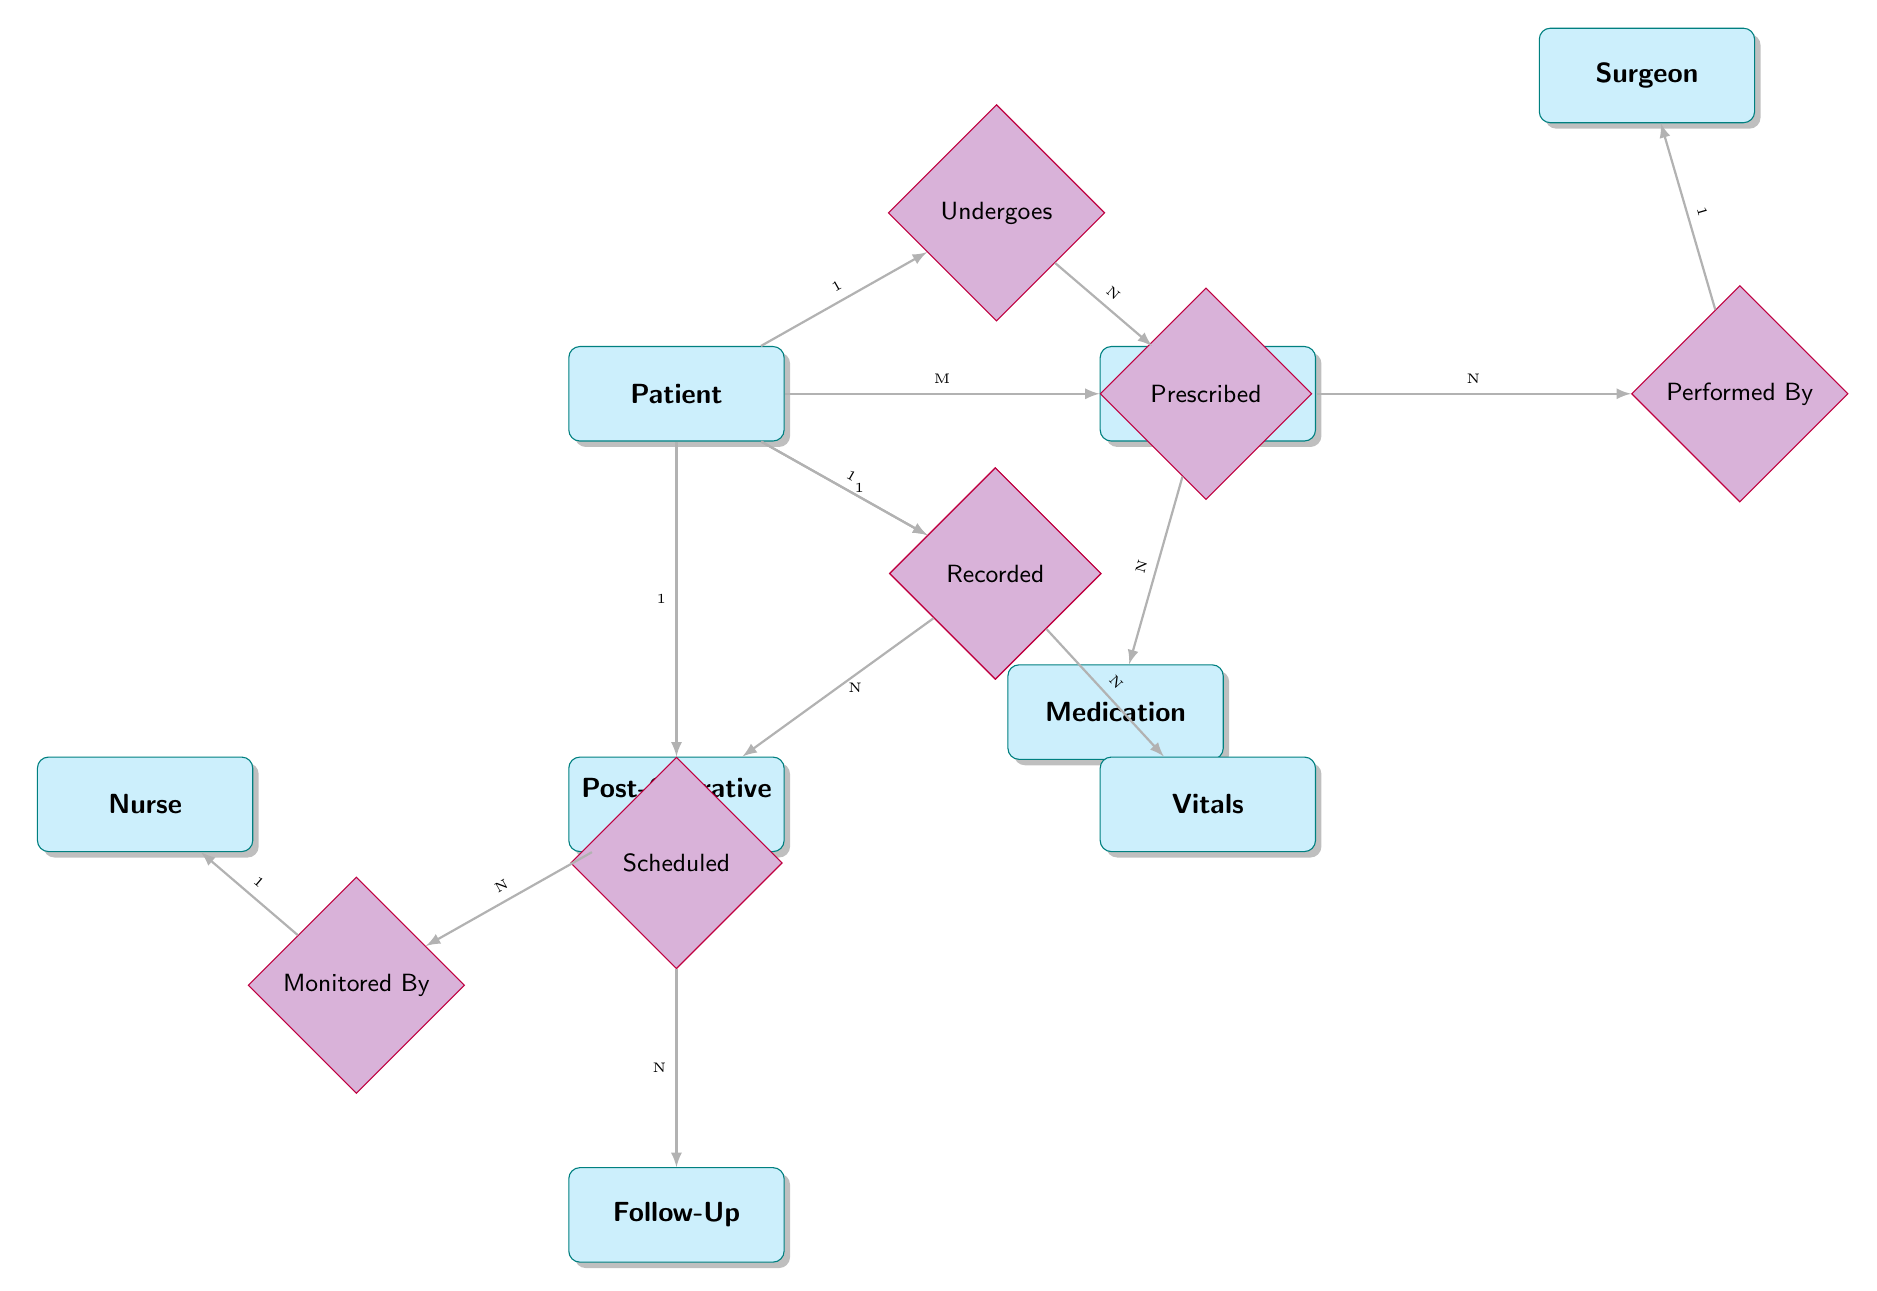What entity is responsible for performing surgeries? The diagram indicates a relationship between the Surgery entity and the Surgeon entity. Specifically, the "Performed By" relationship connects these two, suggesting that the Surgeon is responsible for the surgical procedures.
Answer: Surgeon How many patients can receive postoperative care? The "Receives" relationship shows a connection between the Patient entity and the PostOperativeCare entity with a 1:N cardinality. This means one patient can have multiple entries of postoperative care.
Answer: N Which entity is used to monitor a patient's vitals? The diagram defines a "Monitored By" relationship between the PostOperativeCare entity and the Nurse entity. This indicates that nurses are responsible for monitoring the postoperative care of patients.
Answer: Nurse What is the maximum number of medications that a patient can be prescribed? The diagram specifies a many-to-many (M:N) relationship between Medication and Patient through the "Prescribed" relationship. This indicates that a single patient can have multiple medications prescribed.
Answer: N How many follow-up appointments can a single patient schedule? The "Scheduled" relationship connects the Patient entity and the FollowUp entity with a 1:N cardinality, indicating that a patient can schedule multiple follow-up appointments.
Answer: N What type of relationship is formed between Surgery and Surgeon? The diagram shows an "N:1" relationship between Surgery and Surgeon, which indicates that multiple surgeries can be performed by a single surgeon.
Answer: Performed By What information can be found in the Vitals entity? In the "Vitals" entity, attributes include Heart Rate, Blood Pressure, Temperature, and DateTime, which document the vital signs of patients.
Answer: Heart Rate, Blood Pressure, Temperature, DateTime What is the purpose of the CareDetails attribute in the PostOperativeCare entity? The CareDetails attribute contains specific information on the care provided to the patient post-surgery, indicating the type and nature of postoperative care administered.
Answer: Care Details Who is responsible for monitoring the postoperative care? The diagram shows that the Nurse entity is linked through the "Monitored By" relationship to the PostOperativeCare entity, identifying nurses as responsible for monitoring patient recovery.
Answer: Nurse 